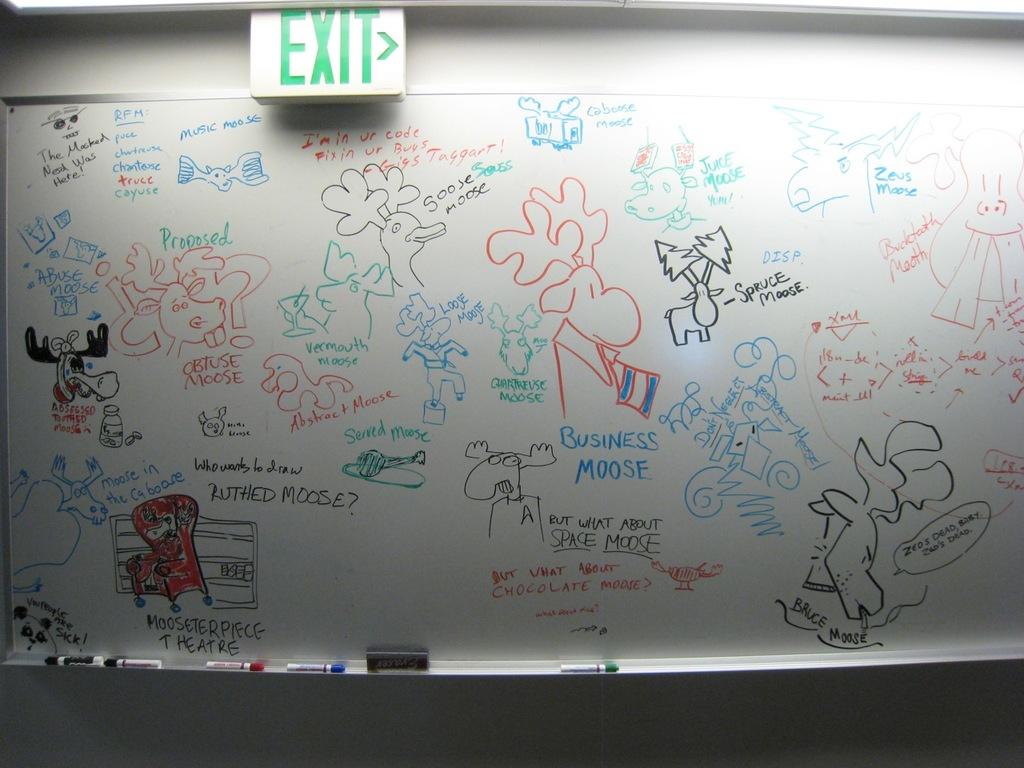What is to the right?
Give a very brief answer. Exit. 